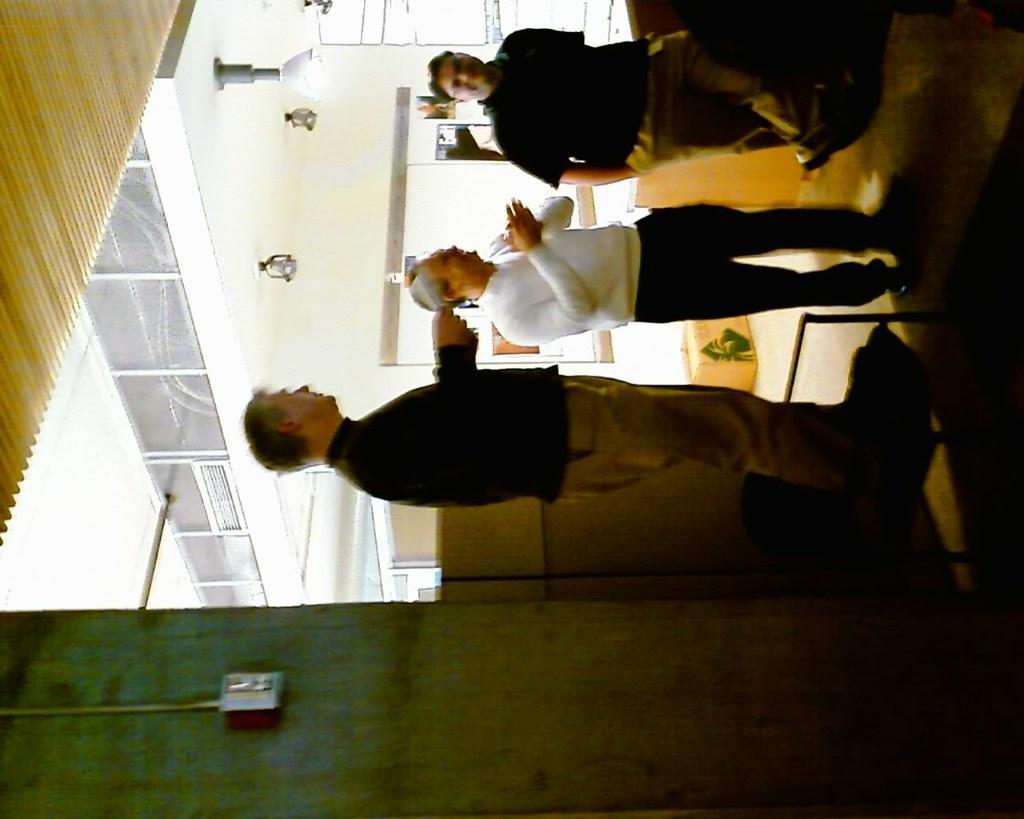Describe this image in one or two sentences. This image is taken indoors. At the bottom of the image there is a wall. On the right side of the image there is a floor. In the middle of the image three men are standing on the floor. In the background there is a wall with a door and there are a few things. On the left side of the image there is a ceiling with a few lights. 